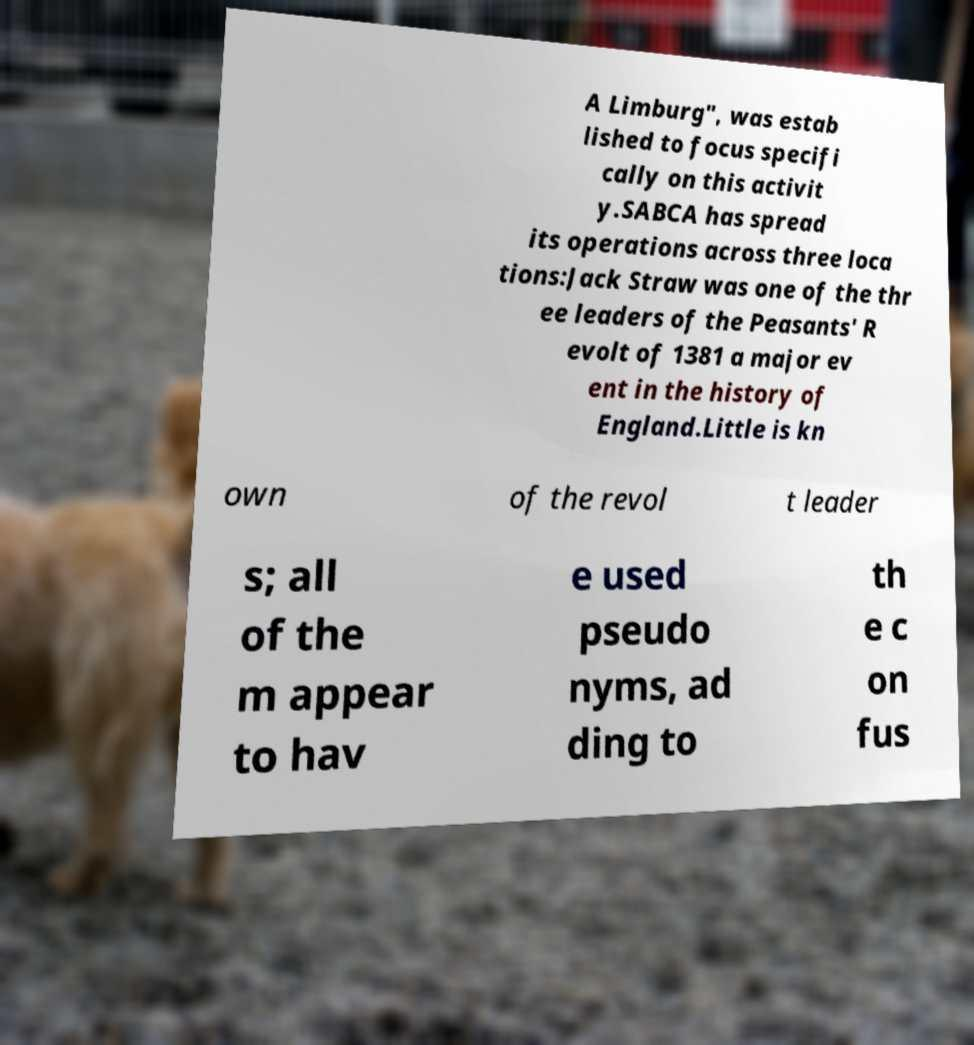For documentation purposes, I need the text within this image transcribed. Could you provide that? A Limburg", was estab lished to focus specifi cally on this activit y.SABCA has spread its operations across three loca tions:Jack Straw was one of the thr ee leaders of the Peasants' R evolt of 1381 a major ev ent in the history of England.Little is kn own of the revol t leader s; all of the m appear to hav e used pseudo nyms, ad ding to th e c on fus 